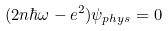Convert formula to latex. <formula><loc_0><loc_0><loc_500><loc_500>( 2 n \hbar { \omega } - e ^ { 2 } ) \psi _ { p h y s } = 0</formula> 